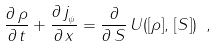Convert formula to latex. <formula><loc_0><loc_0><loc_500><loc_500>\frac { \partial \, \rho } { \partial \, t } + \frac { \partial \, j _ { _ { \psi } } } { \partial \, x } = \frac { \partial } { \partial \, S } \, U ( [ \rho ] , \, [ S ] ) \ ,</formula> 